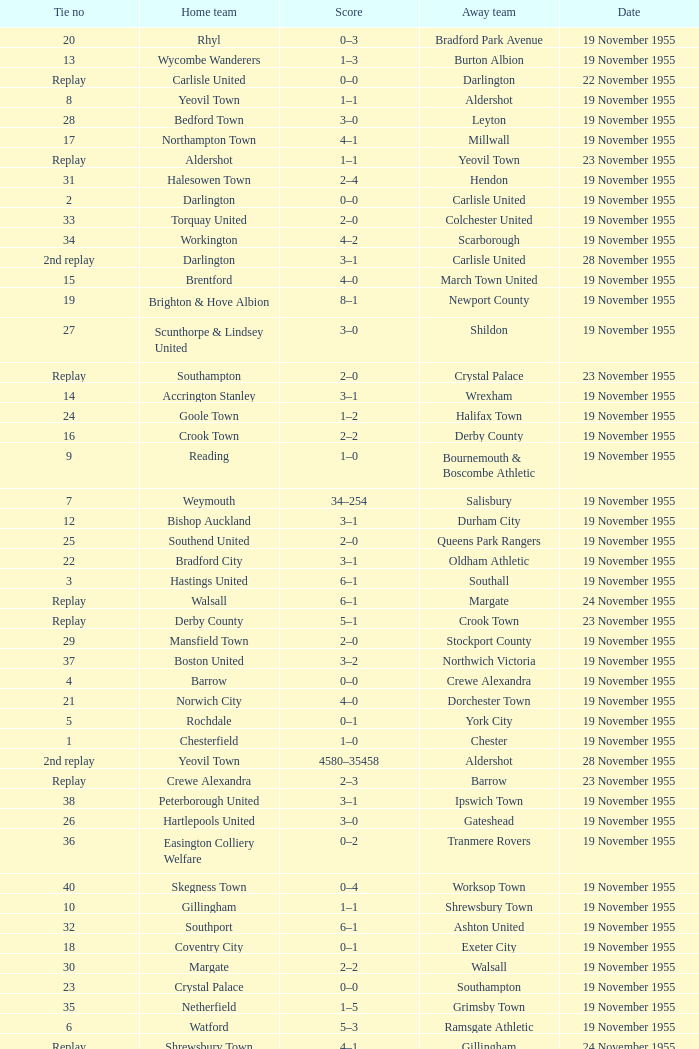What is the home team with scarborough as the away team? Workington. 